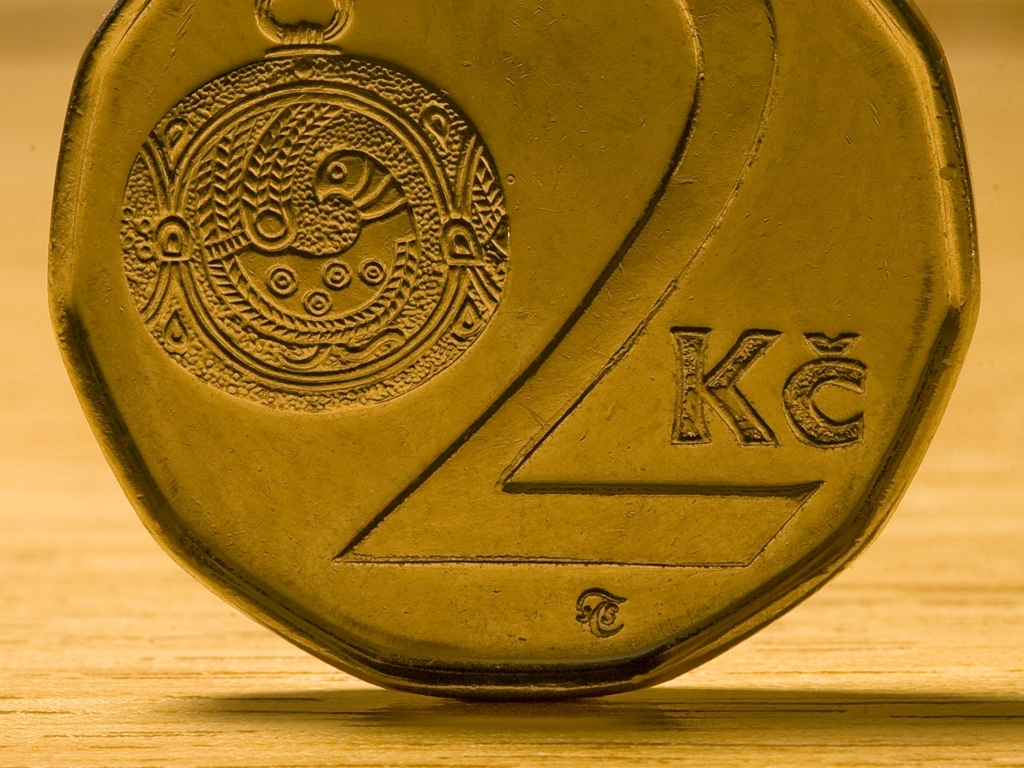Are there any quality issues with this image? The image displays a coin with intricate details and no noticeable visual distortions or artifacts. Its quality is high, showing clear features and texturing that make the design elements stand out, such as the embossed bird and the text on the coin. There is a warm tone to the lighting, and the focus is sharp, with a shallow depth of field that blurs the background, which some might consider a stylistic choice rather than a quality issue. 